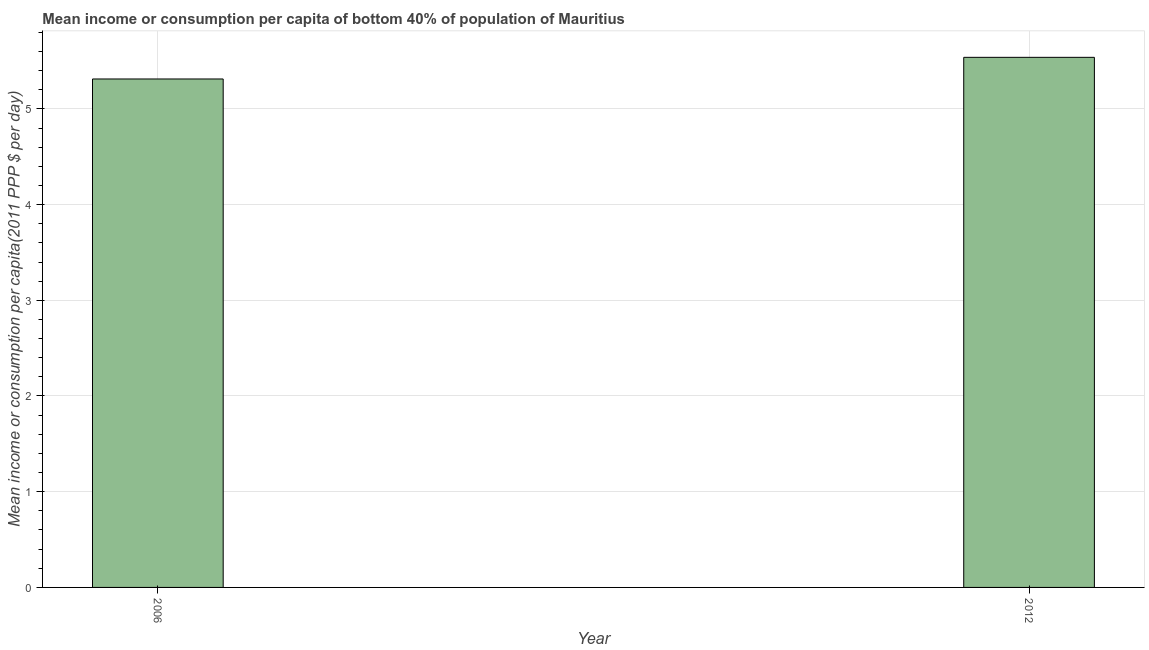Does the graph contain grids?
Offer a terse response. Yes. What is the title of the graph?
Ensure brevity in your answer.  Mean income or consumption per capita of bottom 40% of population of Mauritius. What is the label or title of the X-axis?
Your answer should be very brief. Year. What is the label or title of the Y-axis?
Your response must be concise. Mean income or consumption per capita(2011 PPP $ per day). What is the mean income or consumption in 2012?
Your response must be concise. 5.54. Across all years, what is the maximum mean income or consumption?
Provide a succinct answer. 5.54. Across all years, what is the minimum mean income or consumption?
Provide a succinct answer. 5.31. What is the sum of the mean income or consumption?
Keep it short and to the point. 10.85. What is the difference between the mean income or consumption in 2006 and 2012?
Make the answer very short. -0.23. What is the average mean income or consumption per year?
Ensure brevity in your answer.  5.42. What is the median mean income or consumption?
Offer a terse response. 5.43. Do a majority of the years between 2006 and 2012 (inclusive) have mean income or consumption greater than 1 $?
Offer a very short reply. Yes. What is the ratio of the mean income or consumption in 2006 to that in 2012?
Ensure brevity in your answer.  0.96. Is the mean income or consumption in 2006 less than that in 2012?
Your response must be concise. Yes. How many bars are there?
Make the answer very short. 2. Are all the bars in the graph horizontal?
Your answer should be compact. No. What is the difference between two consecutive major ticks on the Y-axis?
Your response must be concise. 1. What is the Mean income or consumption per capita(2011 PPP $ per day) of 2006?
Offer a terse response. 5.31. What is the Mean income or consumption per capita(2011 PPP $ per day) of 2012?
Make the answer very short. 5.54. What is the difference between the Mean income or consumption per capita(2011 PPP $ per day) in 2006 and 2012?
Make the answer very short. -0.23. 